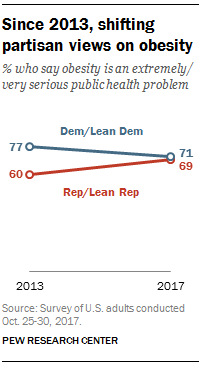Indicate a few pertinent items in this graphic. We will add the average opinion of the two parties from the data of the two years, which is 138.5. The lines are not diverging, contrary to what might be expected. 